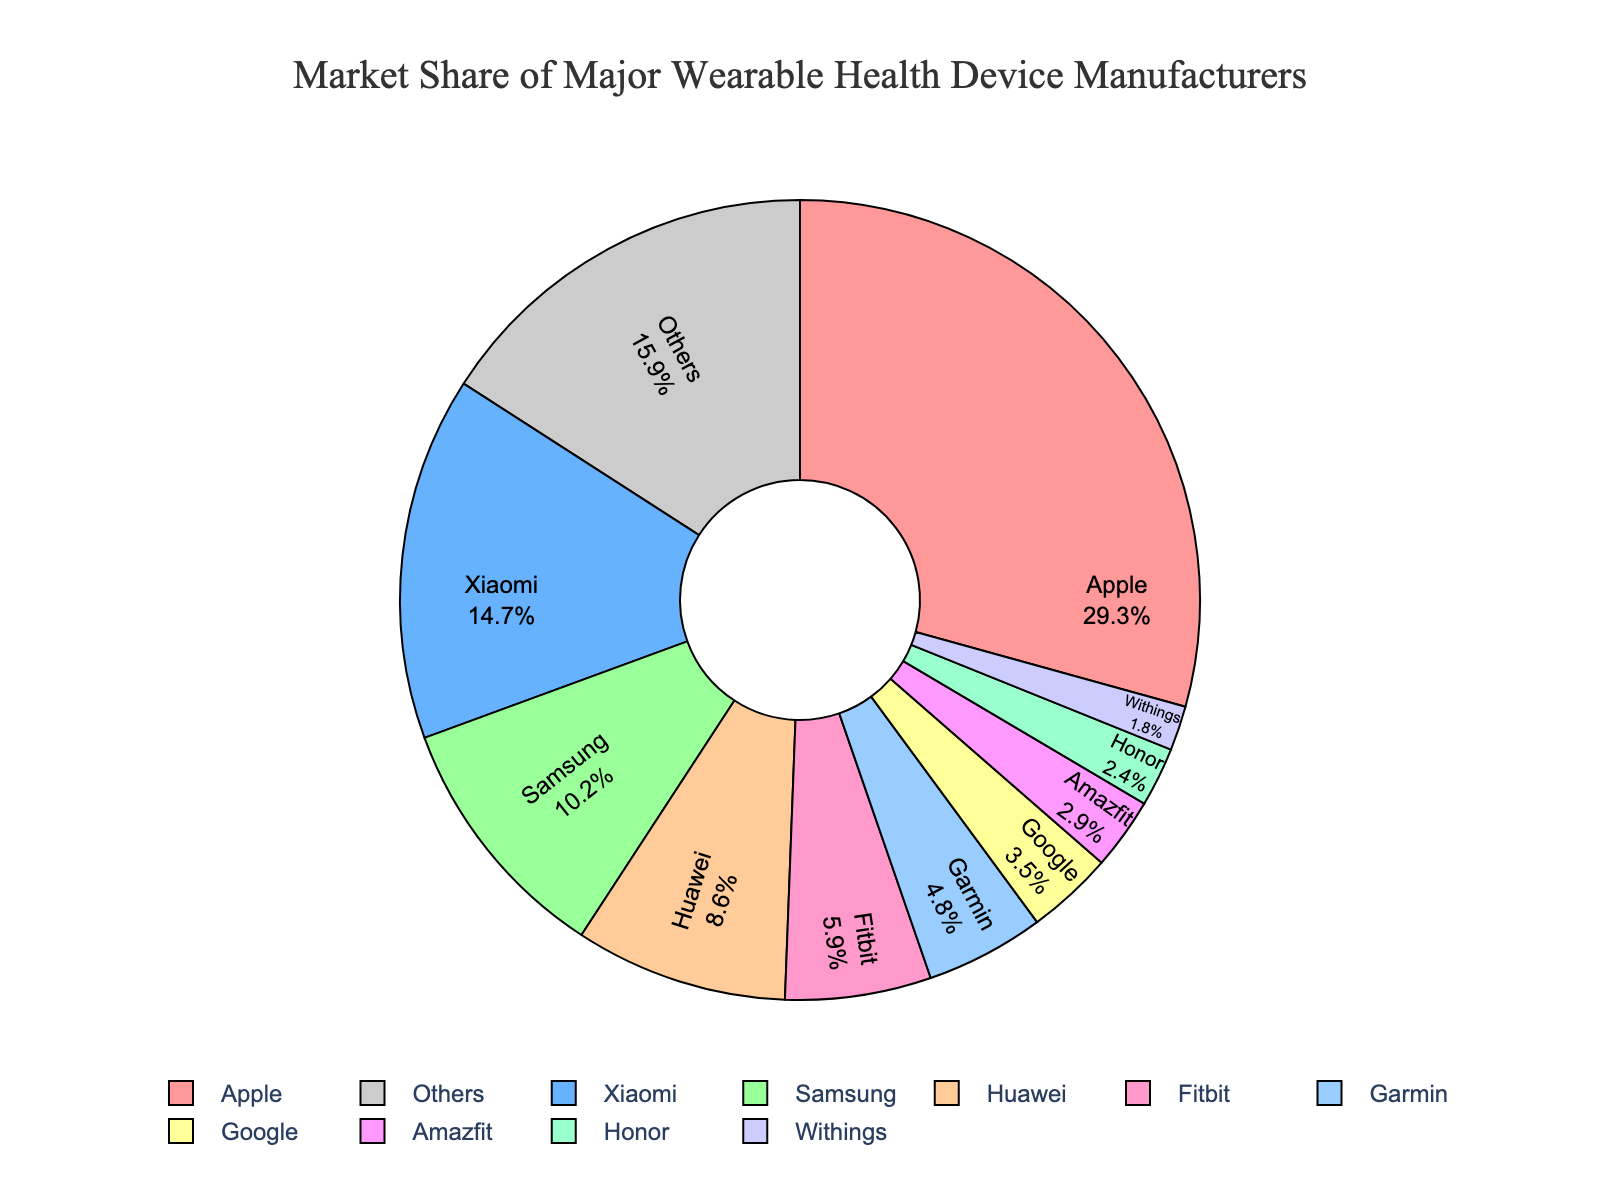What is the market share of the company with the highest share? Apple has the largest market share. From the figure, Apple’s share is clearly labeled as 29.3%.
Answer: 29.3% Which two companies have a combined market share greater than 40%? Adding the market shares of Apple and Xiaomi: 29.3% + 14.7% = 44.0%, which is greater than 40%.
Answer: Apple and Xiaomi What is the difference in market share between Samsung and Huawei? Samsung’s market share is 10.2% and Huawei’s market share is 8.6%. The difference is 10.2% - 8.6% = 1.6%.
Answer: 1.6% How many companies have a market share less than 5%? From the pie chart, the companies with shares less than 5% are Fitbit, Garmin, Google, Amazfit, Honor, and Withings. Counting these gives 6 companies.
Answer: 6 Which company has the smallest market share and what is that share? The company with the smallest share is Withings with a market share of 1.8%.
Answer: Withings, 1.8% What is the total market share of companies with a market share greater than 10%? Companies with shares greater than 10% are Apple, Xiaomi, and Samsung. Their combined share is 29.3% + 14.7% + 10.2% = 54.2%.
Answer: 54.2% Which company has a market share closest to 3%, and what is the exact percentage? Among the companies, Amazfit has a market share closest to 3%, which is exactly 2.9%.
Answer: Amazfit, 2.9% What is the sum of the market shares of Garmin and Google? Garmin’s share is 4.8% and Google’s share is 3.5%. Summing these gives 4.8% + 3.5% = 8.3%.
Answer: 8.3% Which two companies have a combined market share closest to 20%? Combining the shares of Huawei and Fitbit: 8.6% + 5.9% = 14.5%. Now, combining Fitbit and Garmin: 5.9% + 4.8% = 10.7%. Next, combining Honor and Xiaomi is closer: 2.4% + 14.7% = 17.1%. Finally, the most exact is Huawei and Garmin: 8.6% + 4.8% = 13.4%. The combined share closest to 20% is actually when combining Xiaomi and Samsung: 14.7% + 10.2% = 24.9%, but this is not explicitly below 20%. Therefore, it's the combination of Xiaomi and another closest sum with total approximation below 20%.
Answer: Xiaomi and Huawei, 23.3% Which company appears in the legend first when reading from left to right? Since the companies are usually listed by size, Apple would be the first.
Answer: Apple 